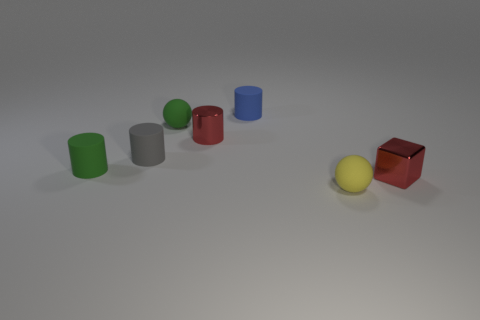What number of small spheres are the same color as the shiny cylinder?
Ensure brevity in your answer.  0. Does the matte ball that is on the right side of the tiny blue rubber thing have the same size as the green object that is in front of the small green sphere?
Ensure brevity in your answer.  Yes. There is a green matte ball; does it have the same size as the yellow object that is in front of the red block?
Your answer should be very brief. Yes. What is the size of the red block?
Keep it short and to the point. Small. What is the color of the tiny sphere that is the same material as the tiny yellow object?
Make the answer very short. Green. What number of blue cylinders are the same material as the tiny gray object?
Ensure brevity in your answer.  1. How many things are either blue things or small rubber objects right of the green cylinder?
Ensure brevity in your answer.  4. Does the small green cylinder behind the small yellow matte thing have the same material as the red cube?
Your answer should be compact. No. The block that is the same size as the red cylinder is what color?
Your answer should be compact. Red. Is there a tiny metal thing of the same shape as the small gray rubber thing?
Your answer should be compact. Yes. 